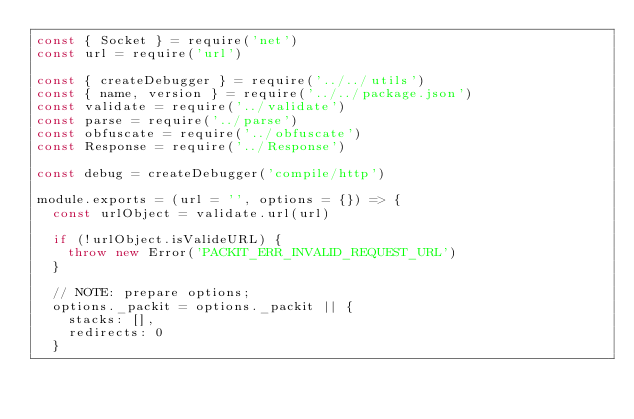Convert code to text. <code><loc_0><loc_0><loc_500><loc_500><_JavaScript_>const { Socket } = require('net')
const url = require('url')

const { createDebugger } = require('../../utils')
const { name, version } = require('../../package.json')
const validate = require('../validate')
const parse = require('../parse')
const obfuscate = require('../obfuscate')
const Response = require('../Response')

const debug = createDebugger('compile/http')

module.exports = (url = '', options = {}) => {
  const urlObject = validate.url(url)

  if (!urlObject.isValideURL) {
    throw new Error('PACKIT_ERR_INVALID_REQUEST_URL')
  }

  // NOTE: prepare options;
  options._packit = options._packit || {
    stacks: [],
    redirects: 0
  }</code> 